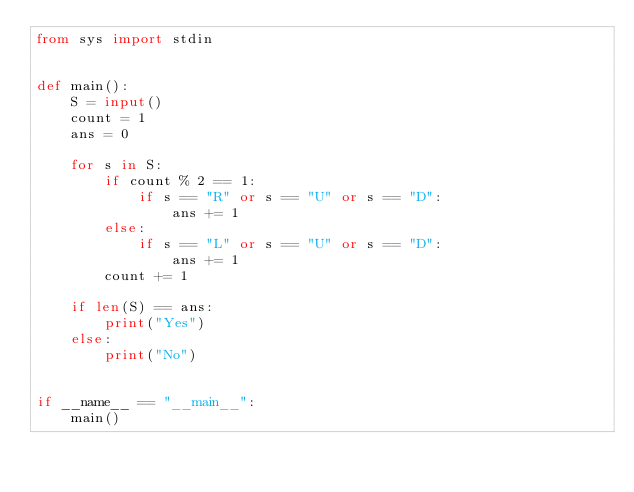Convert code to text. <code><loc_0><loc_0><loc_500><loc_500><_Python_>from sys import stdin


def main():
    S = input()
    count = 1
    ans = 0

    for s in S:
        if count % 2 == 1:
            if s == "R" or s == "U" or s == "D":
                ans += 1
        else:
            if s == "L" or s == "U" or s == "D":
                ans += 1
        count += 1

    if len(S) == ans:
        print("Yes")
    else:
        print("No")


if __name__ == "__main__":
    main()
</code> 